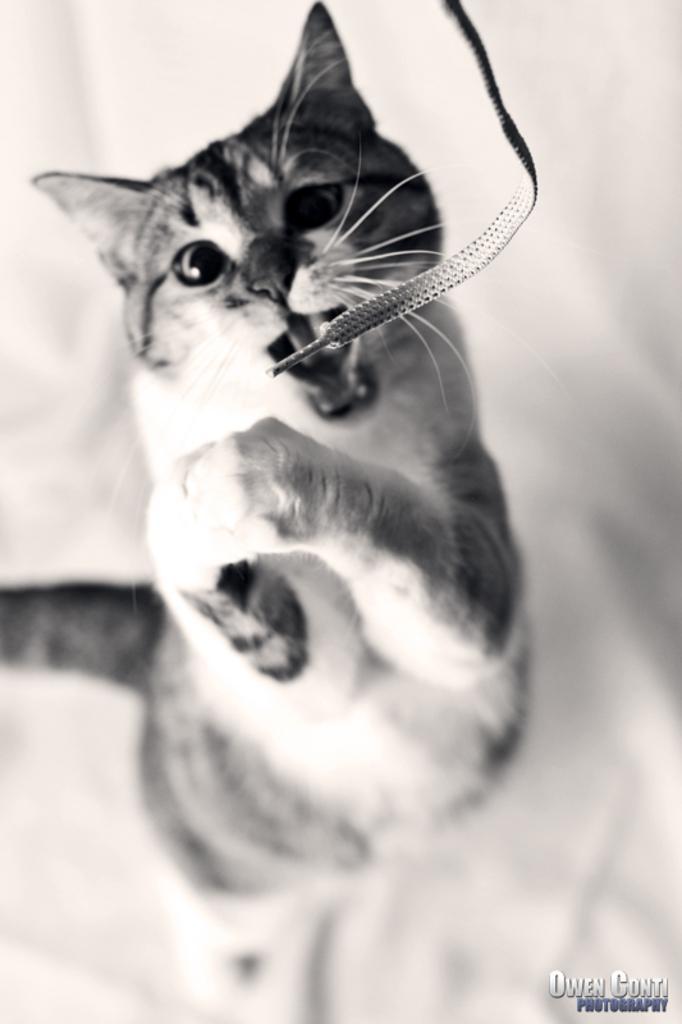Please provide a concise description of this image. This is a black and white image and here we can see a cat and there is a shoe lay. At the bottom, there is some text. 